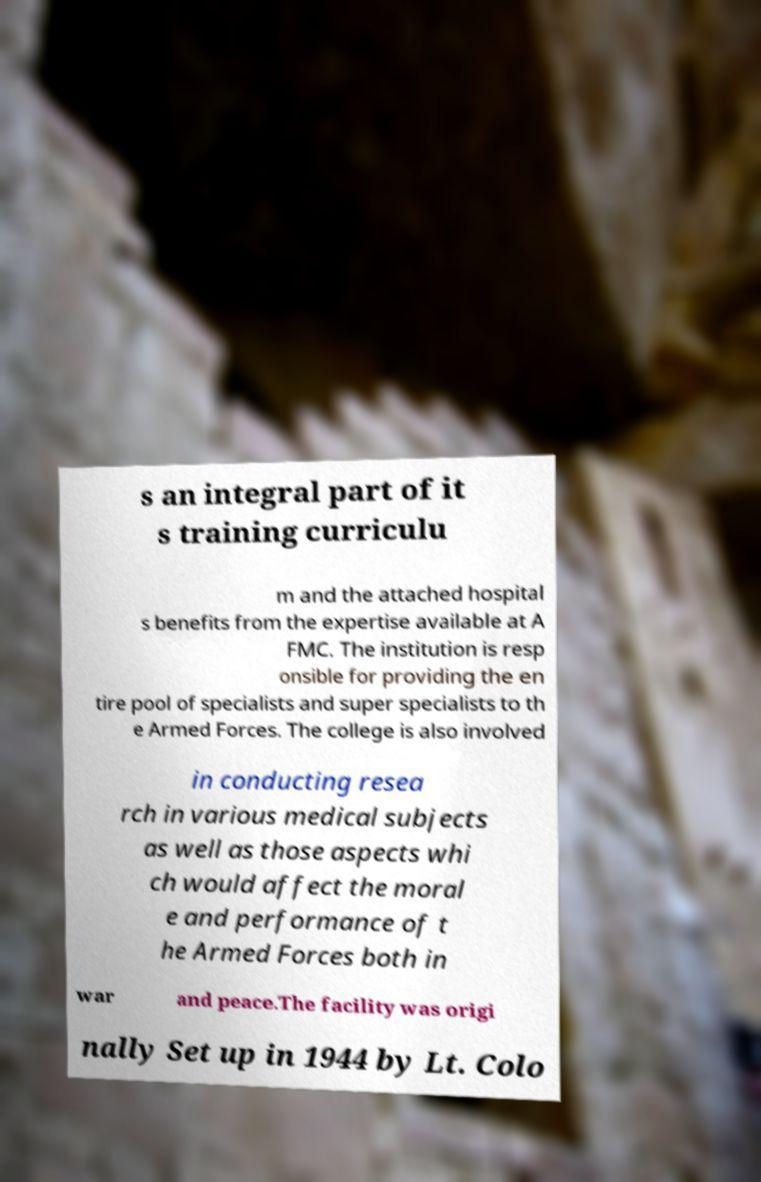There's text embedded in this image that I need extracted. Can you transcribe it verbatim? s an integral part of it s training curriculu m and the attached hospital s benefits from the expertise available at A FMC. The institution is resp onsible for providing the en tire pool of specialists and super specialists to th e Armed Forces. The college is also involved in conducting resea rch in various medical subjects as well as those aspects whi ch would affect the moral e and performance of t he Armed Forces both in war and peace.The facility was origi nally Set up in 1944 by Lt. Colo 